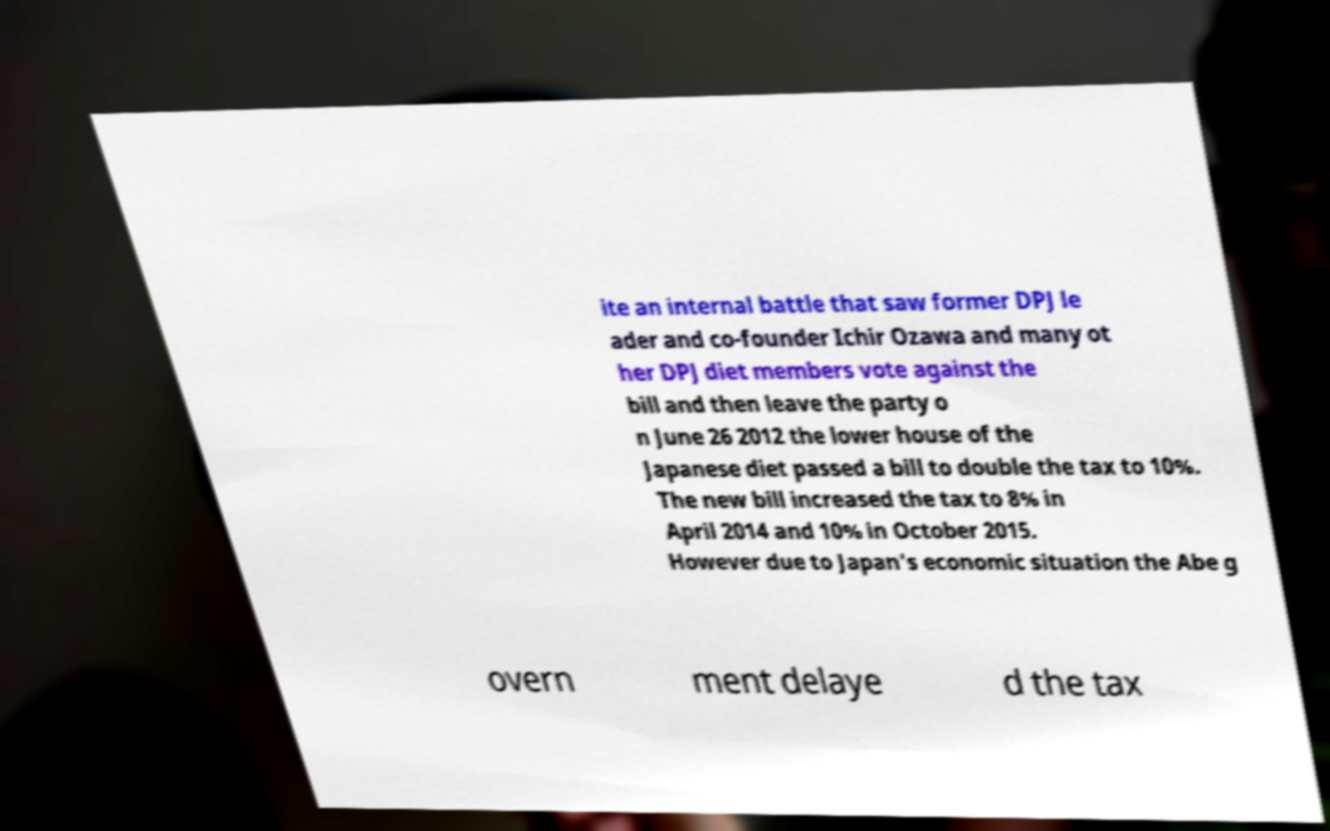Could you assist in decoding the text presented in this image and type it out clearly? ite an internal battle that saw former DPJ le ader and co-founder Ichir Ozawa and many ot her DPJ diet members vote against the bill and then leave the party o n June 26 2012 the lower house of the Japanese diet passed a bill to double the tax to 10%. The new bill increased the tax to 8% in April 2014 and 10% in October 2015. However due to Japan's economic situation the Abe g overn ment delaye d the tax 